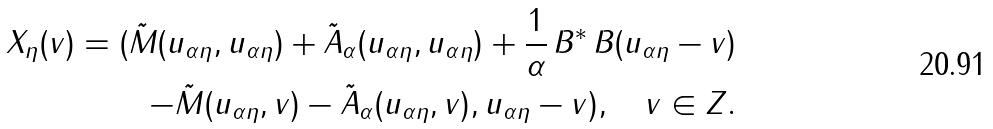Convert formula to latex. <formula><loc_0><loc_0><loc_500><loc_500>X _ { \eta } ( v ) = ( \tilde { M } ( u _ { \alpha \eta } , u _ { \alpha \eta } ) + \tilde { A } _ { \alpha } ( u _ { \alpha \eta } , u _ { \alpha \eta } ) + \frac { 1 } { \alpha } \, B ^ { * } \, B ( u _ { \alpha \eta } - v ) \\ - \tilde { M } ( u _ { \alpha \eta } , v ) - \tilde { A } _ { \alpha } ( u _ { \alpha \eta } , v ) , u _ { \alpha \eta } - v ) , \quad v \in Z .</formula> 